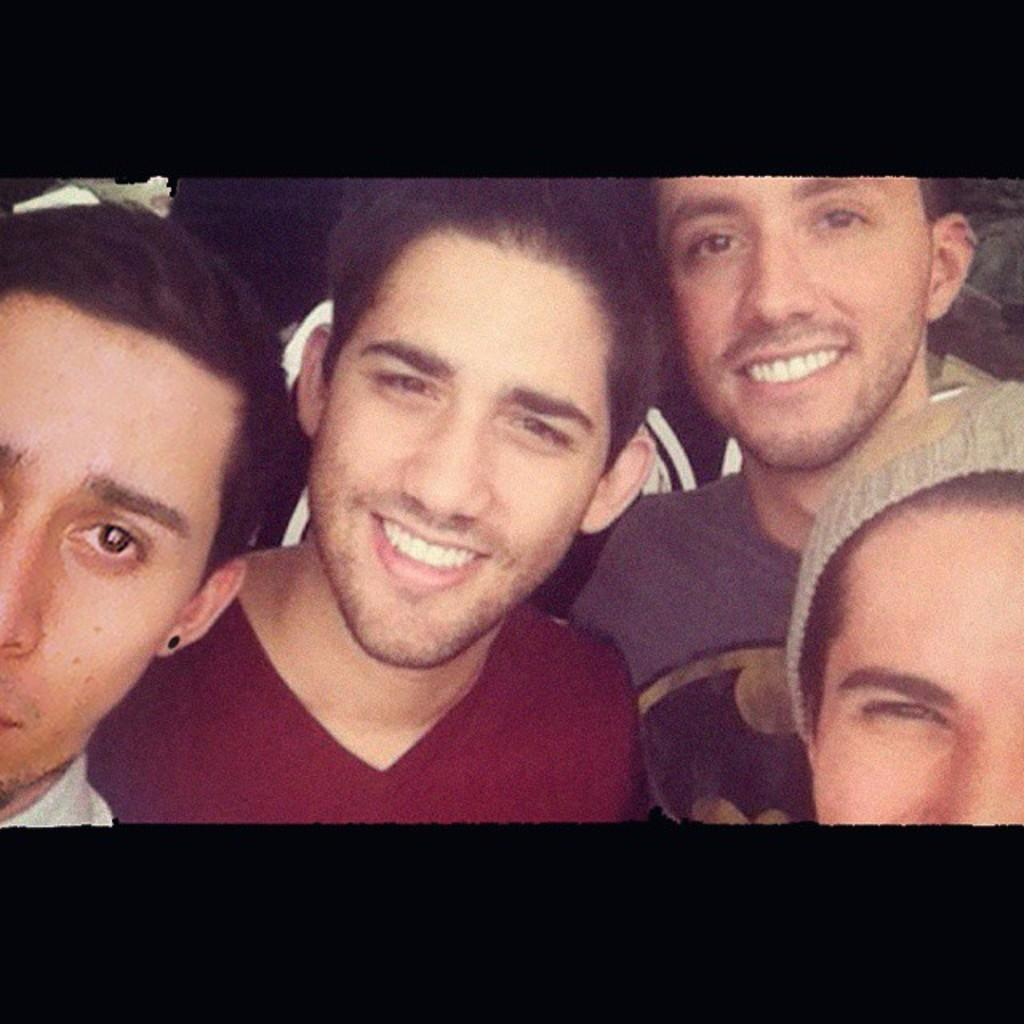What can be observed about the men in the image? There are men in the image, and they have smiles on their faces. Can you describe any specific clothing items worn by the men? One of the men is wearing a cap, and two of the men are wearing t-shirts. What type of bottle is being discussed in the meeting depicted in the image? There is no meeting or bottle present in the image; it features men with smiles on their faces and specific clothing items. 